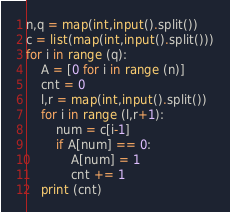<code> <loc_0><loc_0><loc_500><loc_500><_Python_>n,q = map(int,input().split())
c = list(map(int,input().split()))
for i in range (q):
    A = [0 for i in range (n)]
    cnt = 0
    l,r = map(int,input().split())
    for i in range (l,r+1):
        num = c[i-1]
        if A[num] == 0:
            A[num] = 1
            cnt += 1
    print (cnt)</code> 